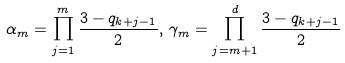Convert formula to latex. <formula><loc_0><loc_0><loc_500><loc_500>\alpha _ { m } = \prod _ { j = 1 } ^ { m } \frac { 3 - q _ { k + j - 1 } } { 2 } , \, \gamma _ { m } = \prod _ { j = m + 1 } ^ { d } \frac { 3 - q _ { k + j - 1 } } { 2 }</formula> 